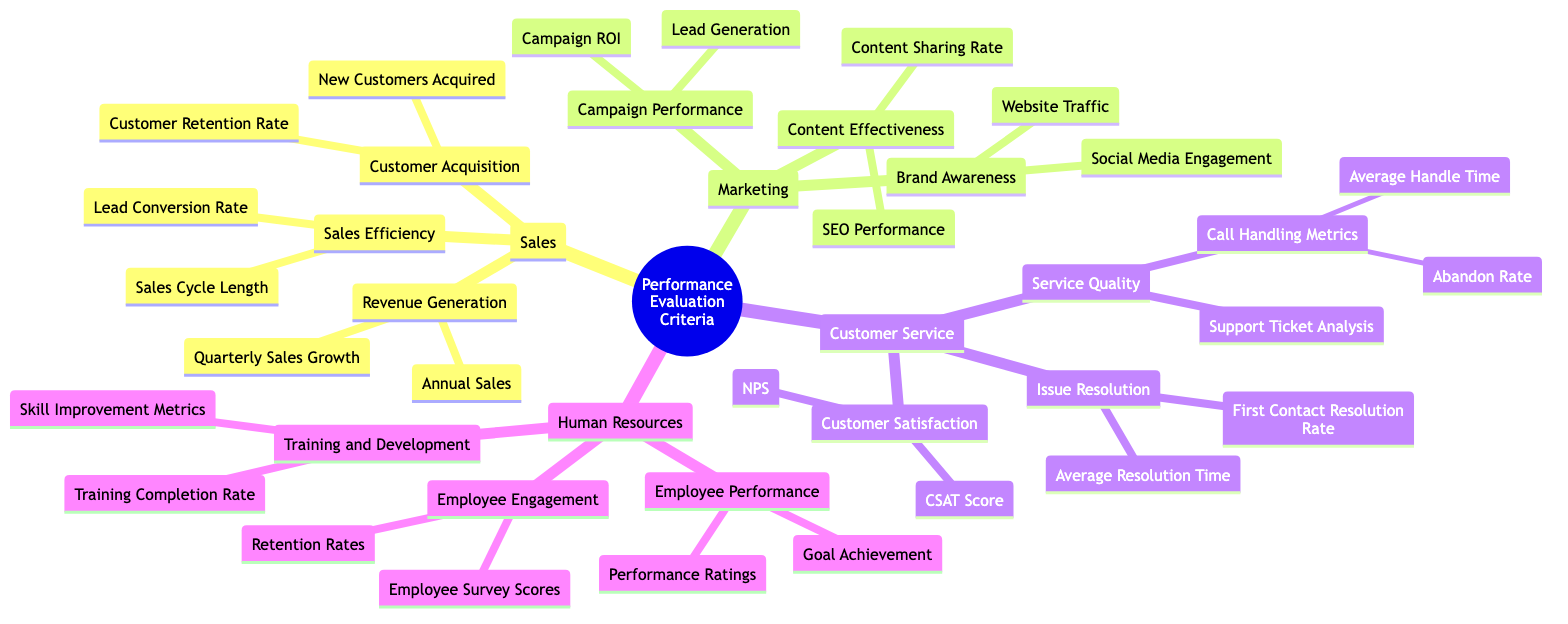What are the three departments listed in the Performance Evaluation Criteria Tree? The diagram branches into four main departments: Sales Department, Marketing Department, Customer Service Department, and Human Resources Department.
Answer: Sales, Marketing, Customer Service, Human Resources How many metrics are under the Sales Department's Customer Acquisition category? The Customer Acquisition category has two metrics listed: New Customers Acquired and Customer Retention Rate. Therefore, there are two metrics in this category.
Answer: 2 What is the average time spent handling a call categorized under? The metric Average Handle Time is found under the Service Quality category, which is a subset of the Customer Service Department's performance evaluation criteria.
Answer: Service Quality What two metrics are measured under the issue resolution evaluation criteria in the Customer Service Department? The Issue Resolution category includes Average Resolution Time and First Contact Resolution Rate as its two main metrics.
Answer: Average Resolution Time and First Contact Resolution Rate Which department has metrics related to training and development? The Human Resources Department specifically includes the Training and Development category, which contains metrics like Training Completion Rate and Skill Improvement Metrics.
Answer: Human Resources Department What is one evaluation method for Campaign Performance in the Marketing Department? Under Campaign Performance, one evaluation method listed is Campaign ROI, which measures the return on investment for marketing campaigns.
Answer: Campaign ROI How are Employee Engagement metrics quantified in the Human Resources Department? Employee Engagement metrics are quantified using Employee Survey Scores and Retention Rates, providing insights into employee satisfaction and retention.
Answer: Employee Survey Scores and Retention Rates What metric measures the percentage growth in sales every quarter within the Sales Department? The Quarterly Sales Growth metric measures the percentage growth in sales every quarter from the Sales Department's performance evaluation criteria.
Answer: Quarterly Sales Growth What does the acronym NPS stand for in the Customer Service Department? NPS stands for Net Promoter Score, which is a metric to gauge customer loyalty and satisfaction found within the Customer Satisfaction category of the Customer Service Department.
Answer: Net Promoter Score 